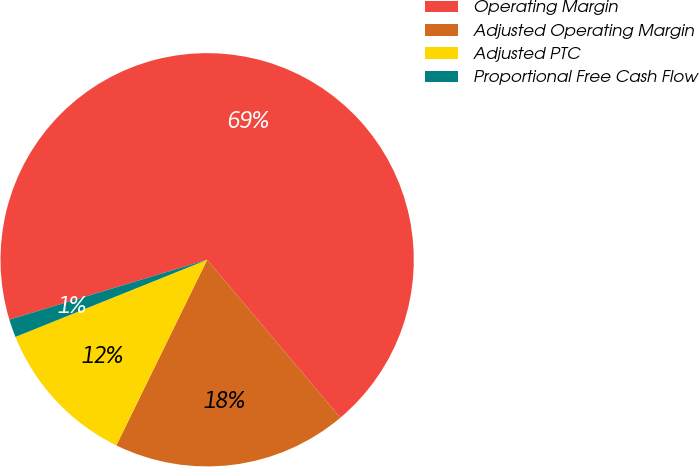Convert chart to OTSL. <chart><loc_0><loc_0><loc_500><loc_500><pie_chart><fcel>Operating Margin<fcel>Adjusted Operating Margin<fcel>Adjusted PTC<fcel>Proportional Free Cash Flow<nl><fcel>68.53%<fcel>18.39%<fcel>11.67%<fcel>1.41%<nl></chart> 